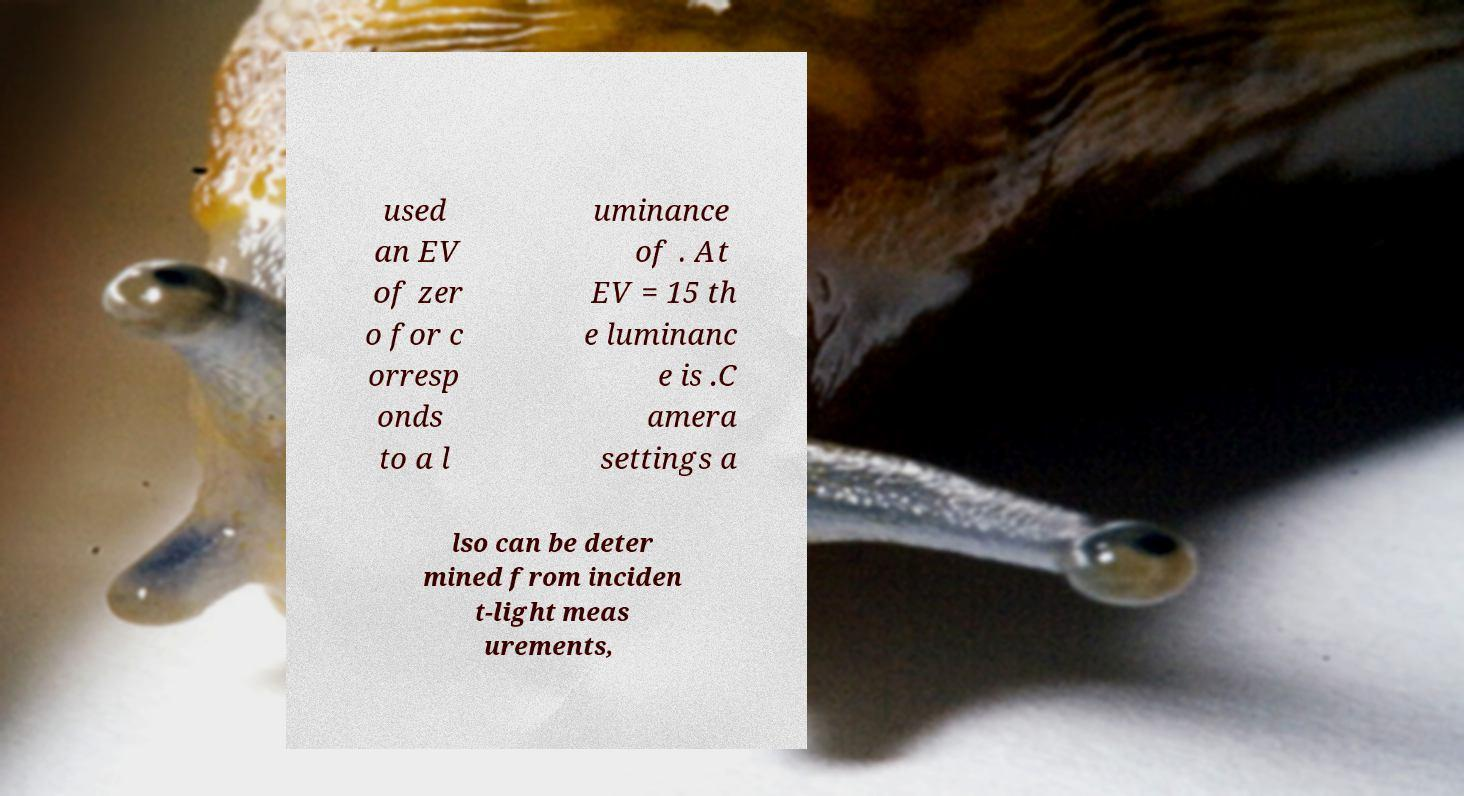Could you assist in decoding the text presented in this image and type it out clearly? used an EV of zer o for c orresp onds to a l uminance of . At EV = 15 th e luminanc e is .C amera settings a lso can be deter mined from inciden t-light meas urements, 